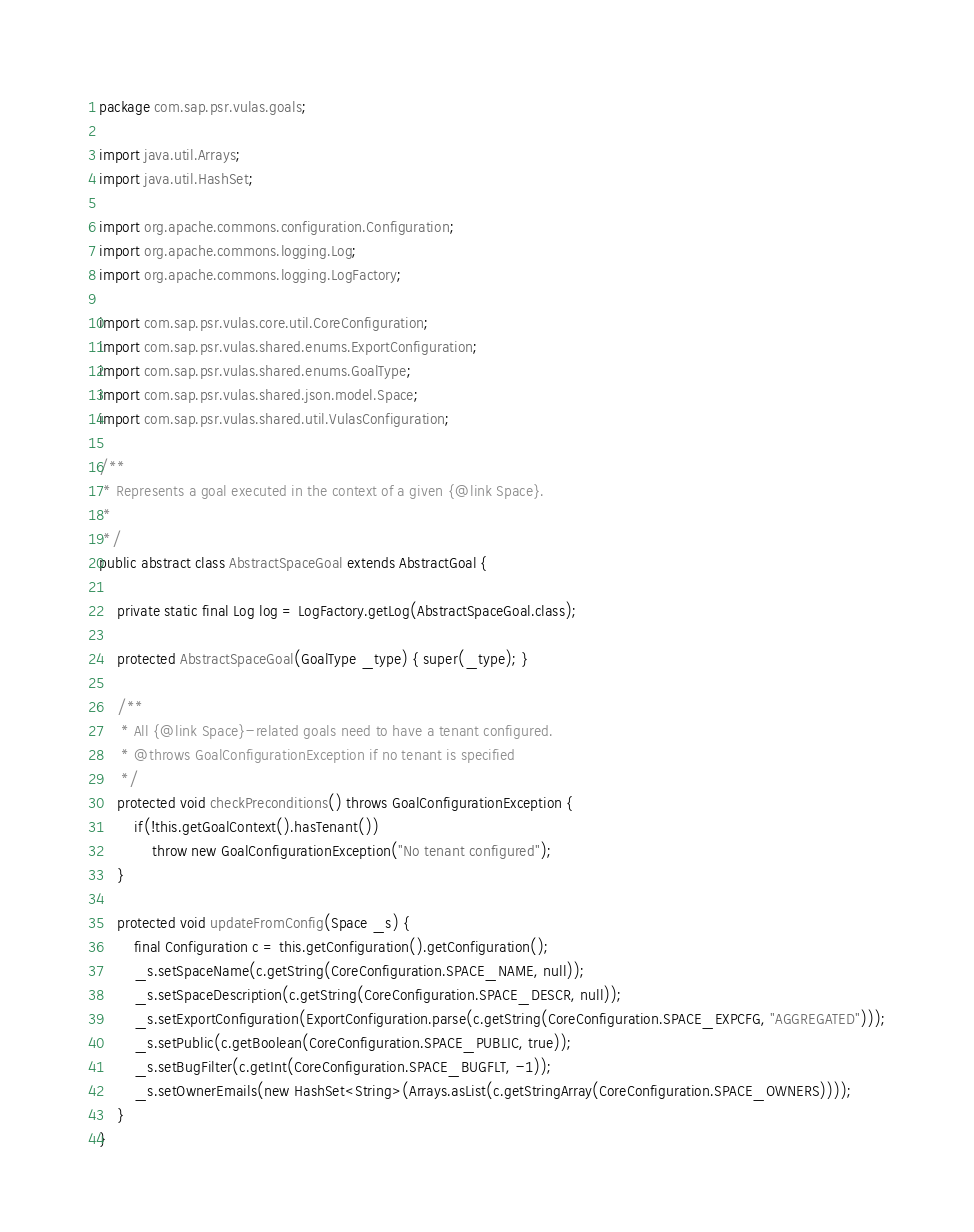Convert code to text. <code><loc_0><loc_0><loc_500><loc_500><_Java_>package com.sap.psr.vulas.goals;

import java.util.Arrays;
import java.util.HashSet;

import org.apache.commons.configuration.Configuration;
import org.apache.commons.logging.Log;
import org.apache.commons.logging.LogFactory;

import com.sap.psr.vulas.core.util.CoreConfiguration;
import com.sap.psr.vulas.shared.enums.ExportConfiguration;
import com.sap.psr.vulas.shared.enums.GoalType;
import com.sap.psr.vulas.shared.json.model.Space;
import com.sap.psr.vulas.shared.util.VulasConfiguration;

/**
 * Represents a goal executed in the context of a given {@link Space}.
 *
 */
public abstract class AbstractSpaceGoal extends AbstractGoal {

	private static final Log log = LogFactory.getLog(AbstractSpaceGoal.class);

	protected AbstractSpaceGoal(GoalType _type) { super(_type); }
	
	/**
	 * All {@link Space}-related goals need to have a tenant configured.
	 * @throws GoalConfigurationException if no tenant is specified
	 */
	protected void checkPreconditions() throws GoalConfigurationException {
		if(!this.getGoalContext().hasTenant())
			throw new GoalConfigurationException("No tenant configured");
	}
	
	protected void updateFromConfig(Space _s) {
		final Configuration c = this.getConfiguration().getConfiguration();
		_s.setSpaceName(c.getString(CoreConfiguration.SPACE_NAME, null));
		_s.setSpaceDescription(c.getString(CoreConfiguration.SPACE_DESCR, null));
		_s.setExportConfiguration(ExportConfiguration.parse(c.getString(CoreConfiguration.SPACE_EXPCFG, "AGGREGATED")));
		_s.setPublic(c.getBoolean(CoreConfiguration.SPACE_PUBLIC, true));
		_s.setBugFilter(c.getInt(CoreConfiguration.SPACE_BUGFLT, -1));
		_s.setOwnerEmails(new HashSet<String>(Arrays.asList(c.getStringArray(CoreConfiguration.SPACE_OWNERS))));
	}
}</code> 